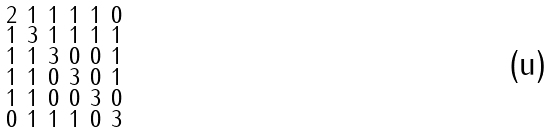<formula> <loc_0><loc_0><loc_500><loc_500>\begin{smallmatrix} 2 & 1 & 1 & 1 & 1 & 0 \\ 1 & 3 & 1 & 1 & 1 & 1 \\ 1 & 1 & 3 & 0 & 0 & 1 \\ 1 & 1 & 0 & 3 & 0 & 1 \\ 1 & 1 & 0 & 0 & 3 & 0 \\ 0 & 1 & 1 & 1 & 0 & 3 \end{smallmatrix}</formula> 